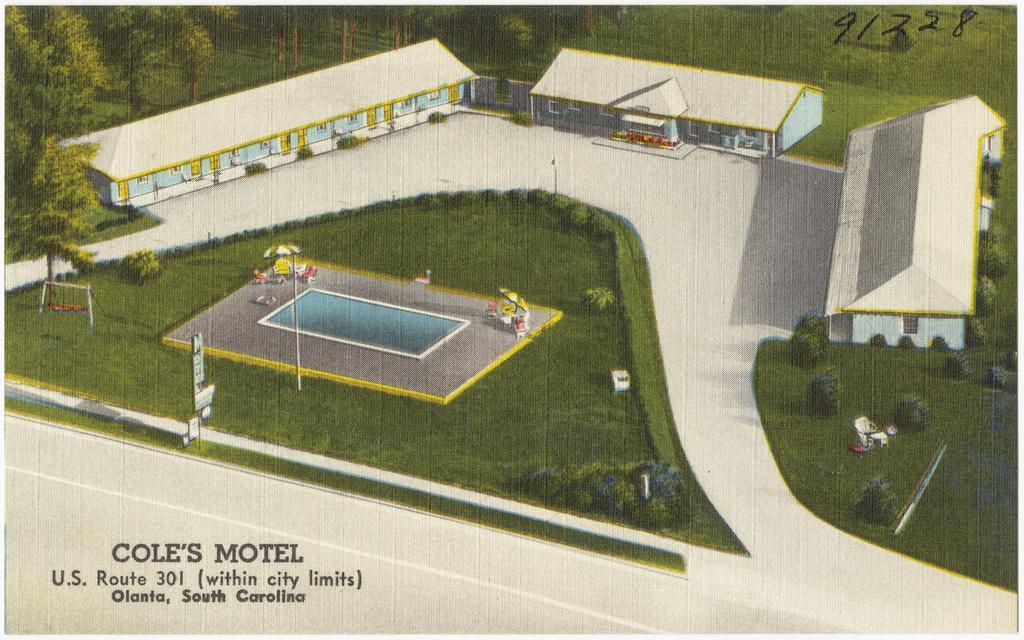Describe this image in one or two sentences. This is an animated image, we can see swimming pool, grassy land, trees and some buildings in the middle of this image. There are some trees in the background and there is a text at the bottom of this image. 